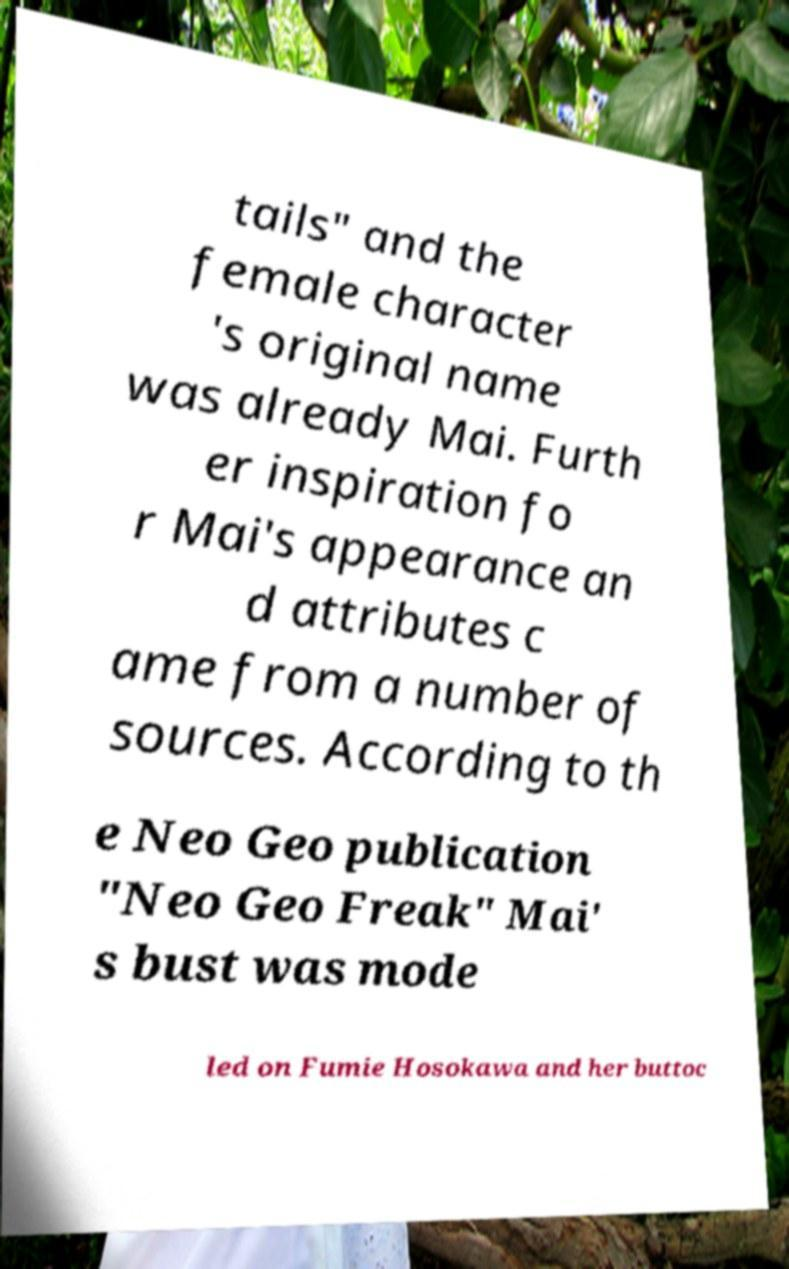Please read and relay the text visible in this image. What does it say? tails" and the female character 's original name was already Mai. Furth er inspiration fo r Mai's appearance an d attributes c ame from a number of sources. According to th e Neo Geo publication "Neo Geo Freak" Mai' s bust was mode led on Fumie Hosokawa and her buttoc 